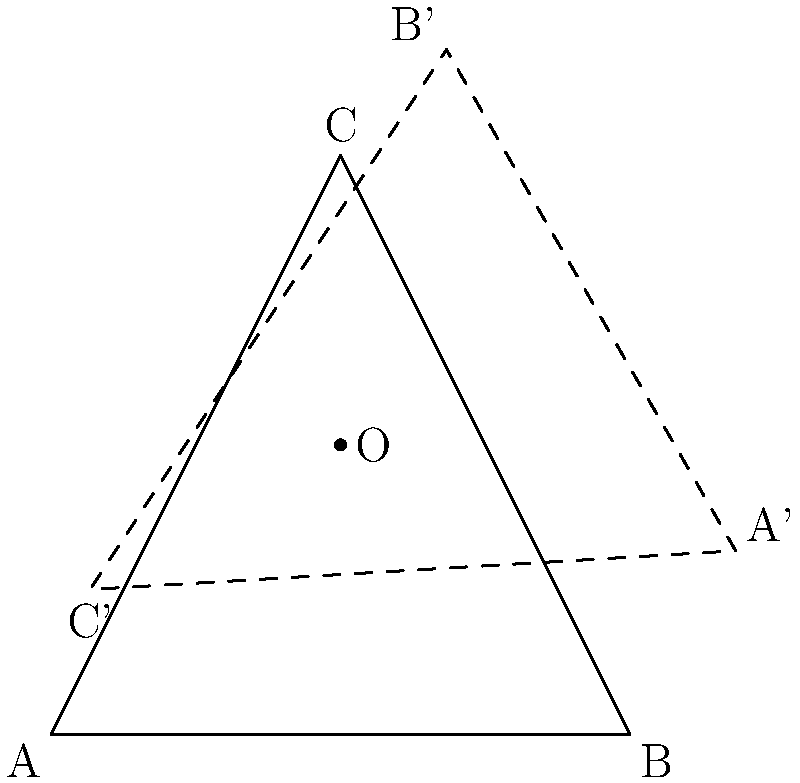In Dostoevsky's "Crime and Punishment," the narrative structure often revolves around the protagonist's internal conflicts. If we represent the three main phases of Raskolnikov's psychological journey (crime, guilt, redemption) as vertices of a triangle ABC, and the center O represents the novel's central theme, how many degrees must the triangle be rotated around O to symbolize the cyclical nature of Raskolnikov's moral transformation? To solve this problem, we need to consider the symmetry in Dostoevsky's narrative structure and apply it to rotational transformations:

1. The triangle ABC represents the three main phases of Raskolnikov's psychological journey:
   A: Crime
   B: Guilt
   C: Redemption

2. The center O represents the novel's central theme, which remains constant throughout the narrative.

3. The cyclical nature of Raskolnikov's moral transformation suggests a complete revolution around the central theme.

4. In geometry, a complete revolution is 360°.

5. To maintain the symmetry of the narrative structure, we need to find a rotation that brings the triangle back to its original position while passing through all three phases equally.

6. The smallest such rotation is 120°, as it divides the 360° revolution into three equal parts:

   $$\frac{360°}{3} = 120°$$

7. This 120° rotation symbolizes the transition from one phase to another in Raskolnikov's journey:
   - A (Crime) rotates to B' (Guilt)
   - B (Guilt) rotates to C' (Redemption)
   - C (Redemption) rotates to A' (back to Crime, completing the cycle)

8. This rotation reflects the cyclical and transformative nature of Raskolnikov's psychological journey in "Crime and Punishment," where each phase leads inevitably to the next, creating a symmetrical narrative structure.
Answer: 120° 